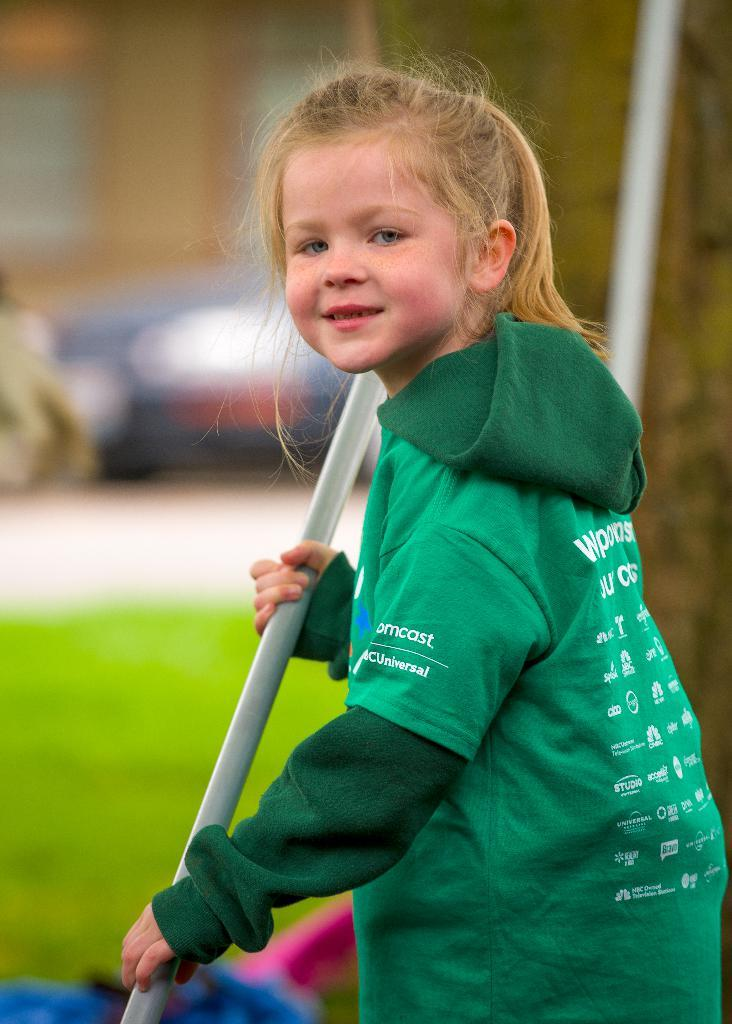Who is the main subject in the image? There is a girl in the image. What is the girl wearing? The girl is wearing a green color hoodie. Are there any specific details on the hoodie? Yes, there are words and logos on the hoodie. What is the girl holding in the image? The girl is holding a silver color rod. How would you describe the background of the image? The background of the image is blurred. How many cakes are being prepared in the image? There are no cakes present in the image. What type of dirt can be seen on the girl's shoes in the image? There is no dirt visible on the girl's shoes in the image, and no shoes are even mentioned in the provided facts. 